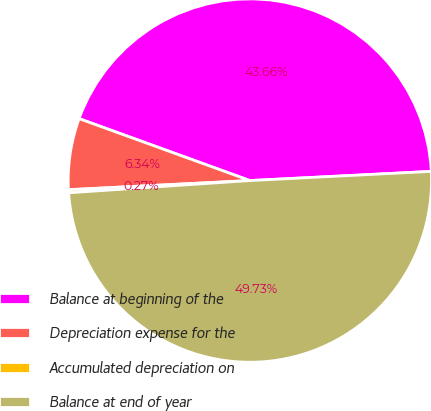Convert chart to OTSL. <chart><loc_0><loc_0><loc_500><loc_500><pie_chart><fcel>Balance at beginning of the<fcel>Depreciation expense for the<fcel>Accumulated depreciation on<fcel>Balance at end of year<nl><fcel>43.66%<fcel>6.34%<fcel>0.27%<fcel>49.73%<nl></chart> 